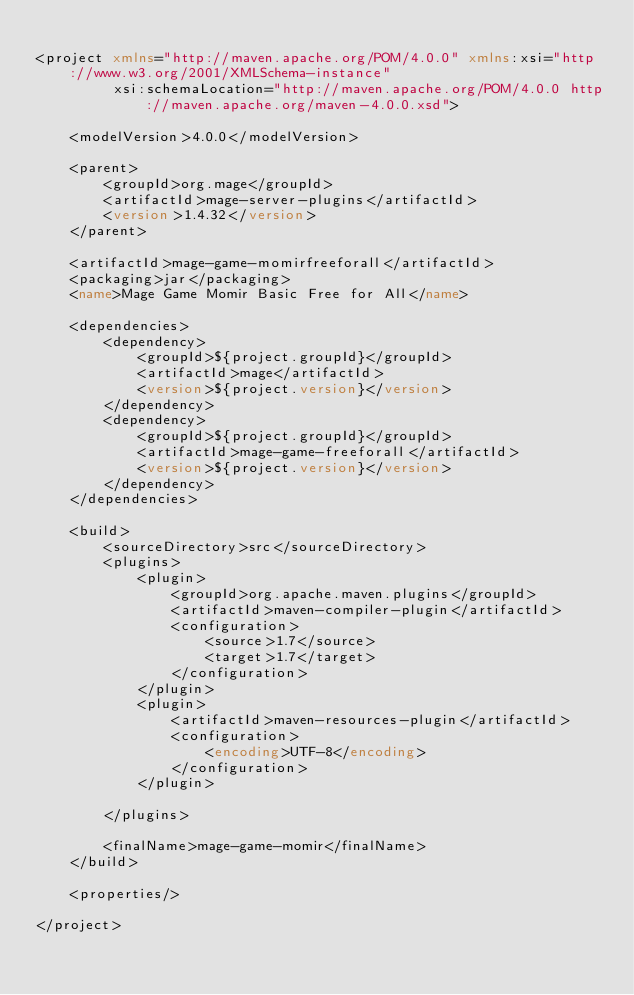Convert code to text. <code><loc_0><loc_0><loc_500><loc_500><_XML_>
<project xmlns="http://maven.apache.org/POM/4.0.0" xmlns:xsi="http://www.w3.org/2001/XMLSchema-instance" 
         xsi:schemaLocation="http://maven.apache.org/POM/4.0.0 http://maven.apache.org/maven-4.0.0.xsd">
    
    <modelVersion>4.0.0</modelVersion>
    
    <parent>
        <groupId>org.mage</groupId>
        <artifactId>mage-server-plugins</artifactId>
        <version>1.4.32</version>
    </parent>
    
    <artifactId>mage-game-momirfreeforall</artifactId>
    <packaging>jar</packaging>
    <name>Mage Game Momir Basic Free for All</name>
    
    <dependencies>
        <dependency>
            <groupId>${project.groupId}</groupId>
            <artifactId>mage</artifactId>
            <version>${project.version}</version>
        </dependency>
        <dependency>
            <groupId>${project.groupId}</groupId>
            <artifactId>mage-game-freeforall</artifactId>
            <version>${project.version}</version>
        </dependency>
    </dependencies>
    
    <build>
        <sourceDirectory>src</sourceDirectory>
        <plugins>
            <plugin>
                <groupId>org.apache.maven.plugins</groupId>
                <artifactId>maven-compiler-plugin</artifactId>
                <configuration>
                    <source>1.7</source>
                    <target>1.7</target>
                </configuration>
            </plugin>
            <plugin>
                <artifactId>maven-resources-plugin</artifactId>
                <configuration>
                    <encoding>UTF-8</encoding>
                </configuration>
            </plugin>

        </plugins>

        <finalName>mage-game-momir</finalName>
    </build>
    
    <properties/>
    
</project>
</code> 